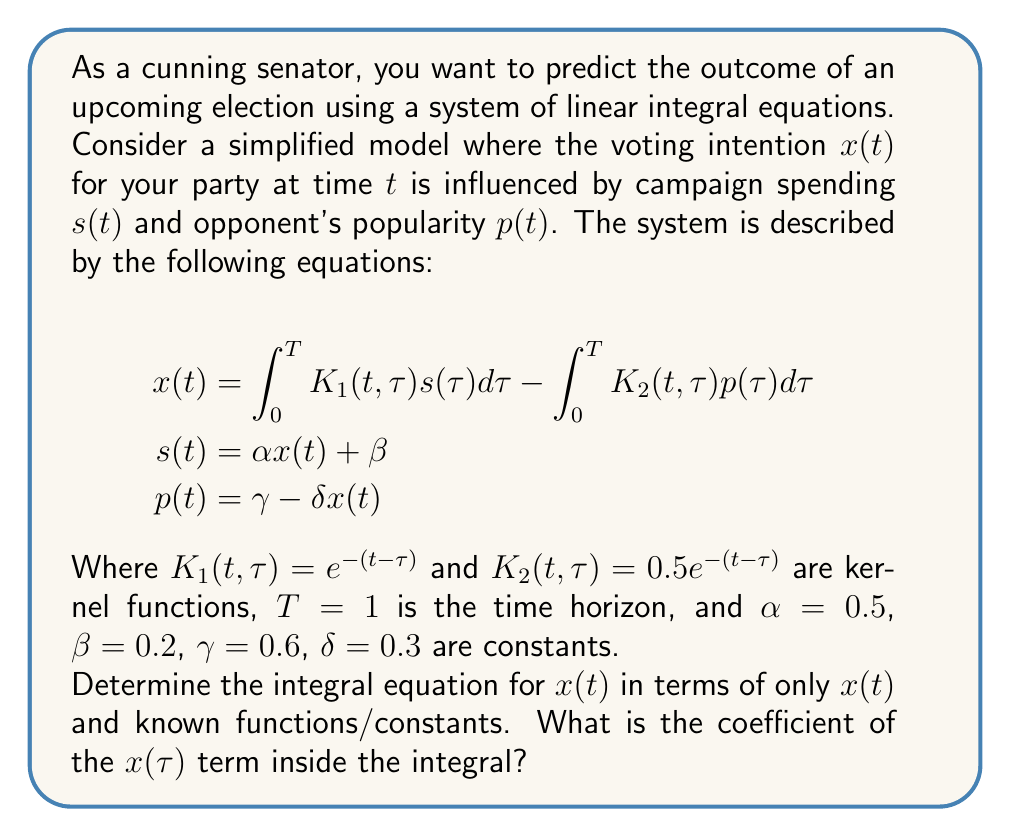Provide a solution to this math problem. Let's approach this step-by-step:

1) First, we substitute the expressions for $s(t)$ and $p(t)$ into the equation for $x(t)$:

   $$x(t) = \int_0^T K_1(t,\tau)(\alpha x(\tau) + \beta)d\tau - \int_0^T K_2(t,\tau)(\gamma - \delta x(\tau))d\tau$$

2) Expanding this expression:

   $$x(t) = \int_0^T K_1(t,\tau)\alpha x(\tau)d\tau + \int_0^T K_1(t,\tau)\beta d\tau - \int_0^T K_2(t,\tau)\gamma d\tau + \int_0^T K_2(t,\tau)\delta x(\tau)d\tau$$

3) Grouping terms with $x(\tau)$:

   $$x(t) = \int_0^T (K_1(t,\tau)\alpha + K_2(t,\tau)\delta) x(\tau)d\tau + \int_0^T K_1(t,\tau)\beta d\tau - \int_0^T K_2(t,\tau)\gamma d\tau$$

4) Substituting the given kernel functions and constants:

   $$x(t) = \int_0^1 (e^{-(t-\tau)} \cdot 0.5 + 0.5e^{-(t-\tau)} \cdot 0.3) x(\tau)d\tau + \int_0^1 e^{-(t-\tau)} \cdot 0.2 d\tau - \int_0^1 0.5e^{-(t-\tau)} \cdot 0.6 d\tau$$

5) Simplifying the coefficient of $x(\tau)$:

   $$x(t) = \int_0^1 (0.5e^{-(t-\tau)} + 0.15e^{-(t-\tau)}) x(\tau)d\tau + \int_0^1 0.2e^{-(t-\tau)} d\tau - \int_0^1 0.3e^{-(t-\tau)} d\tau$$

   $$x(t) = \int_0^1 0.65e^{-(t-\tau)} x(\tau)d\tau + \int_0^1 0.2e^{-(t-\tau)} d\tau - \int_0^1 0.3e^{-(t-\tau)} d\tau$$

Therefore, the coefficient of the $x(\tau)$ term inside the integral is $0.65e^{-(t-\tau)}$.
Answer: $0.65e^{-(t-\tau)}$ 